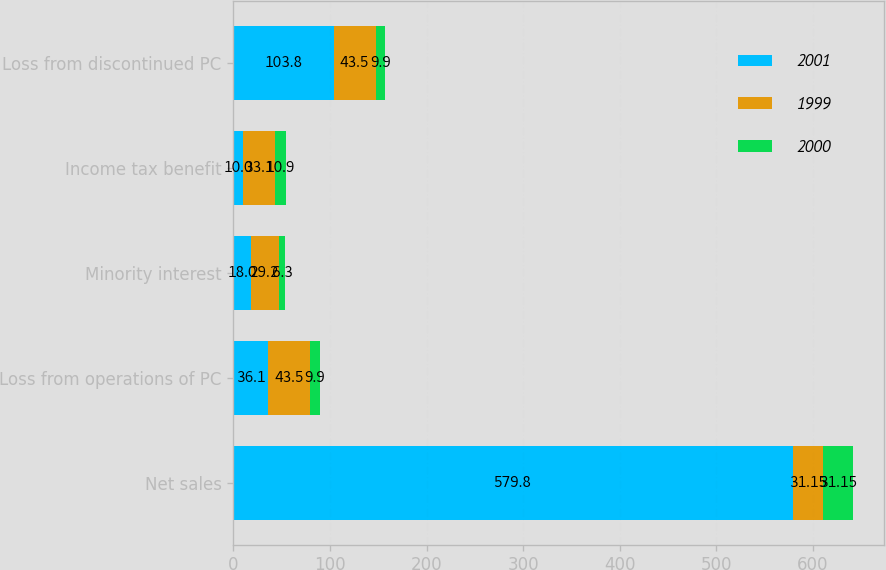Convert chart to OTSL. <chart><loc_0><loc_0><loc_500><loc_500><stacked_bar_chart><ecel><fcel>Net sales<fcel>Loss from operations of PC<fcel>Minority interest<fcel>Income tax benefit<fcel>Loss from discontinued PC<nl><fcel>2001<fcel>579.8<fcel>36.1<fcel>18<fcel>10<fcel>103.8<nl><fcel>1999<fcel>31.15<fcel>43.5<fcel>29.2<fcel>33.1<fcel>43.5<nl><fcel>2000<fcel>31.15<fcel>9.9<fcel>6.3<fcel>10.9<fcel>9.9<nl></chart> 